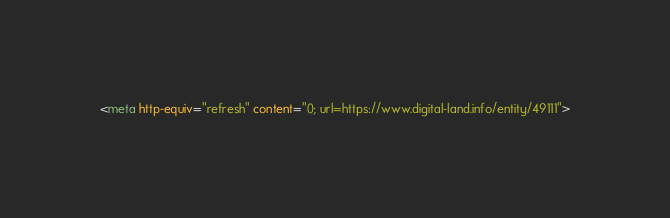<code> <loc_0><loc_0><loc_500><loc_500><_HTML_><meta http-equiv="refresh" content="0; url=https://www.digital-land.info/entity/49111"></code> 